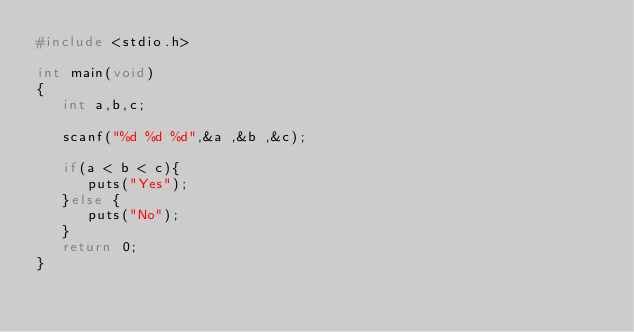Convert code to text. <code><loc_0><loc_0><loc_500><loc_500><_C_>#include <stdio.h>

int main(void)
{
   int a,b,c;

   scanf("%d %d %d",&a ,&b ,&c);

   if(a < b < c){
      puts("Yes");
   }else {
      puts("No");
   }
   return 0;
}</code> 